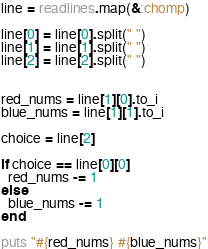Convert code to text. <code><loc_0><loc_0><loc_500><loc_500><_Ruby_>line = readlines.map(&:chomp)

line[0] = line[0].split(" ")
line[1] = line[1].split(" ")
line[2] = line[2].split(" ")


red_nums = line[1][0].to_i
blue_nums = line[1][1].to_i

choice = line[2]

if choice == line[0][0]
  red_nums -= 1
else
  blue_nums -= 1
end

puts "#{red_nums} #{blue_nums}"
</code> 